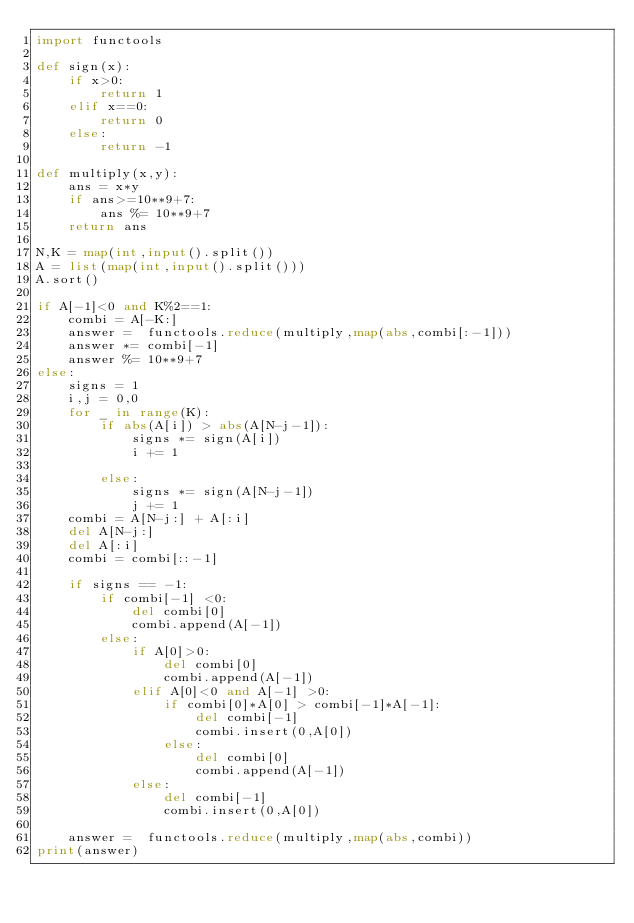<code> <loc_0><loc_0><loc_500><loc_500><_Python_>import functools

def sign(x):
    if x>0:
        return 1
    elif x==0:
        return 0
    else:
        return -1
    
def multiply(x,y):
    ans = x*y
    if ans>=10**9+7:
        ans %= 10**9+7
    return ans

N,K = map(int,input().split())
A = list(map(int,input().split()))
A.sort()

if A[-1]<0 and K%2==1:
    combi = A[-K:]
    answer =  functools.reduce(multiply,map(abs,combi[:-1]))
    answer *= combi[-1]
    answer %= 10**9+7
else:
    signs = 1
    i,j = 0,0
    for _ in range(K):
        if abs(A[i]) > abs(A[N-j-1]):
            signs *= sign(A[i])
            i += 1
            
        else:
            signs *= sign(A[N-j-1])
            j += 1
    combi = A[N-j:] + A[:i]
    del A[N-j:]
    del A[:i]
    combi = combi[::-1]     
       
    if signs == -1:
        if combi[-1] <0:
            del combi[0]
            combi.append(A[-1])
        else:
            if A[0]>0:
                del combi[0]
                combi.append(A[-1])
            elif A[0]<0 and A[-1] >0:
                if combi[0]*A[0] > combi[-1]*A[-1]:
                    del combi[-1]
                    combi.insert(0,A[0])
                else:
                    del combi[0]
                    combi.append(A[-1])
            else:
                del combi[-1]
                combi.insert(0,A[0]) 

    answer =  functools.reduce(multiply,map(abs,combi))
print(answer)</code> 